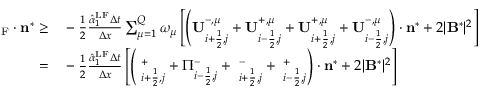Convert formula to latex. <formula><loc_0><loc_0><loc_500><loc_500>\begin{array} { r l } { { \Pi } _ { F } \cdot n ^ { * } \geq } & - \frac { 1 } { 2 } \frac { \hat { \alpha } _ { 1 } ^ { L F } \Delta t } { \Delta x } \sum _ { \mu = 1 } ^ { Q } \omega _ { \mu } \left [ \left ( U _ { i + \frac { 1 } { 2 } , j } ^ { - , \mu } + U _ { i - \frac { 1 } { 2 } , j } ^ { + , \mu } + U _ { i + \frac { 1 } { 2 } , j } ^ { + , \mu } + U _ { i - \frac { 1 } { 2 } , j } ^ { - , \mu } \right ) \cdot n ^ { * } + 2 | B ^ { * } | ^ { 2 } \right ] } \\ { = } & - \frac { 1 } { 2 } \frac { \hat { \alpha } _ { 1 } ^ { L F } \Delta t } { \Delta x } \left [ \left ( { \Pi } _ { i + \frac { 1 } { 2 } , j } ^ { + } + \Pi _ { i - \frac { 1 } { 2 } , j } ^ { - } + { \Pi } _ { i + \frac { 1 } { 2 } , j } ^ { - } + { \Pi } _ { i - \frac { 1 } { 2 } , j } ^ { + } \right ) \cdot n ^ { * } + 2 | B ^ { * } | ^ { 2 } \right ] } \end{array}</formula> 